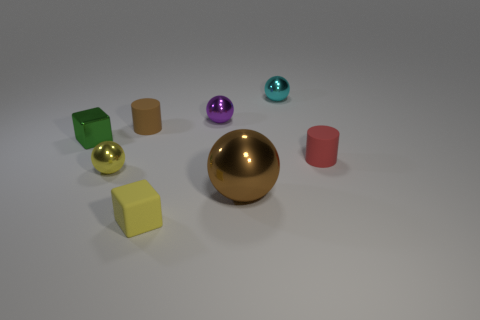Subtract 1 balls. How many balls are left? 3 Add 1 big metal cylinders. How many objects exist? 9 Subtract all cylinders. How many objects are left? 6 Add 3 cyan metallic spheres. How many cyan metallic spheres are left? 4 Add 7 large brown matte things. How many large brown matte things exist? 7 Subtract 0 gray cubes. How many objects are left? 8 Subtract all large shiny objects. Subtract all cyan metal objects. How many objects are left? 6 